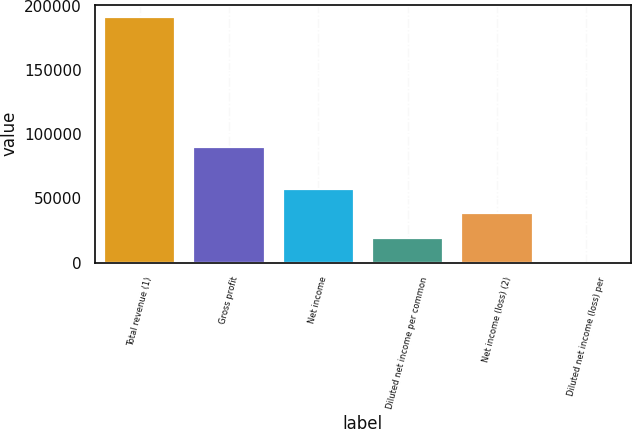<chart> <loc_0><loc_0><loc_500><loc_500><bar_chart><fcel>Total revenue (1)<fcel>Gross profit<fcel>Net income<fcel>Diluted net income per common<fcel>Net income (loss) (2)<fcel>Diluted net income (loss) per<nl><fcel>191505<fcel>90113<fcel>57451.7<fcel>19150.7<fcel>38301.2<fcel>0.25<nl></chart> 